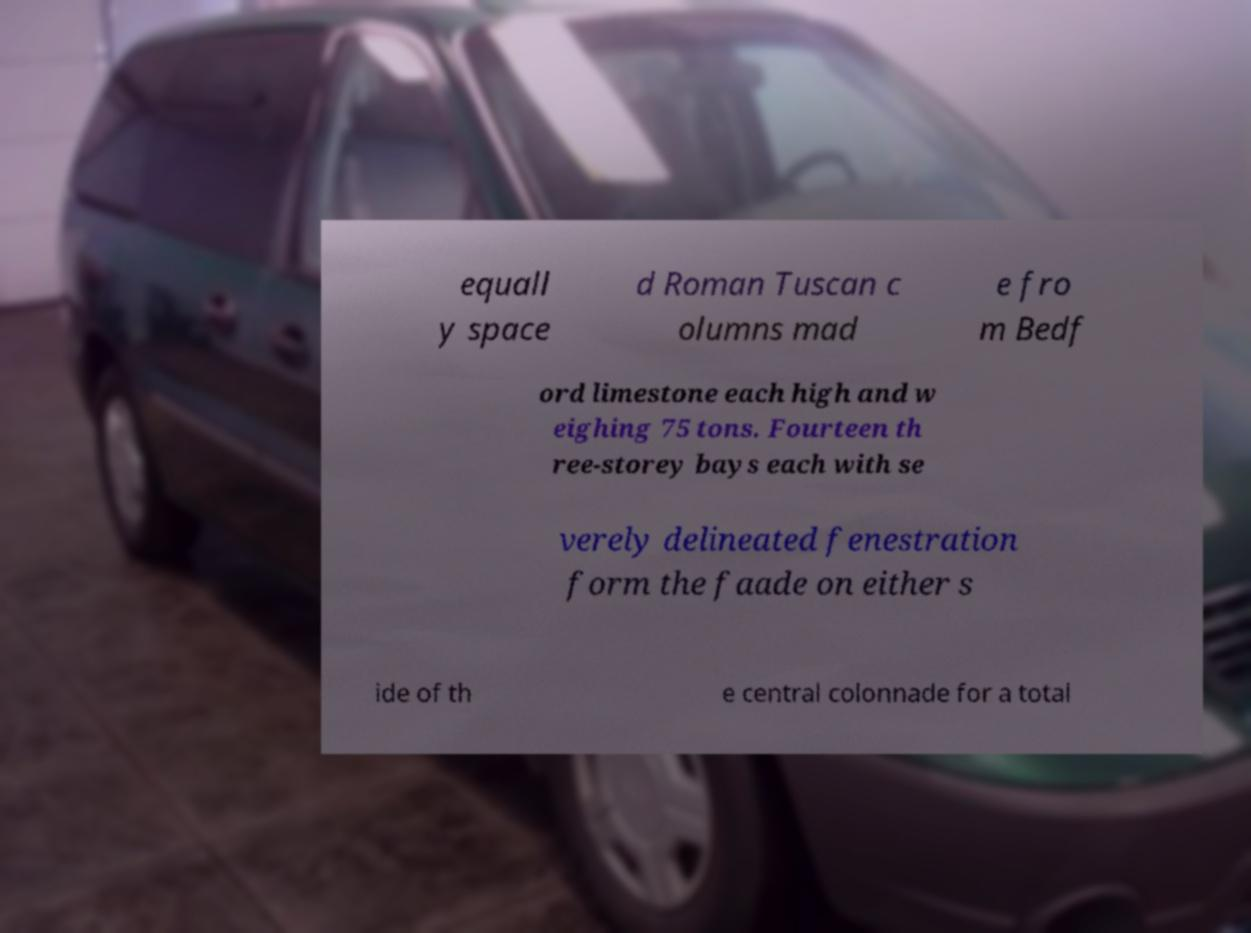Please read and relay the text visible in this image. What does it say? equall y space d Roman Tuscan c olumns mad e fro m Bedf ord limestone each high and w eighing 75 tons. Fourteen th ree-storey bays each with se verely delineated fenestration form the faade on either s ide of th e central colonnade for a total 